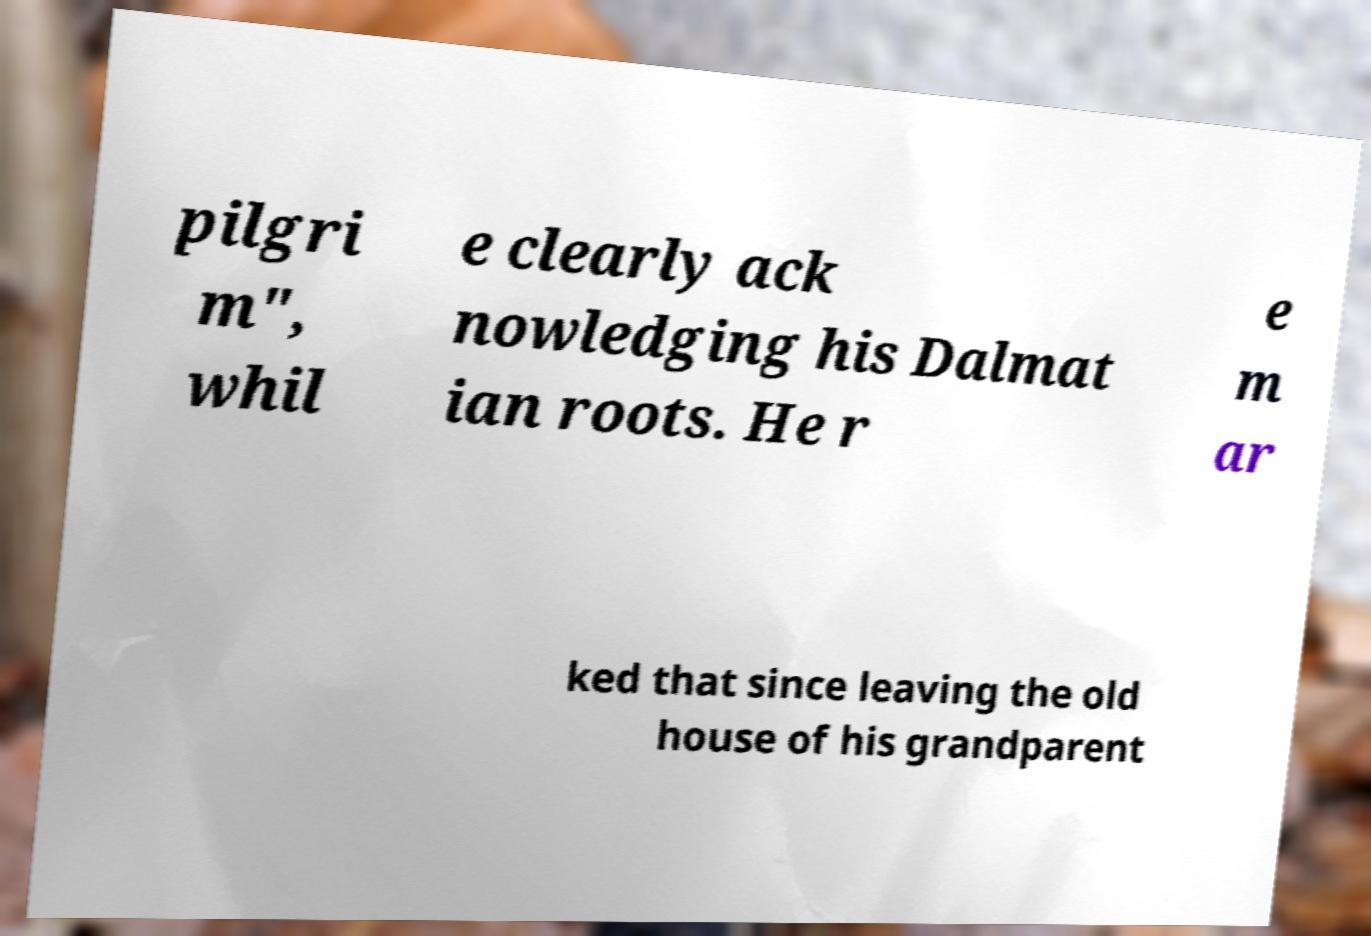What messages or text are displayed in this image? I need them in a readable, typed format. pilgri m", whil e clearly ack nowledging his Dalmat ian roots. He r e m ar ked that since leaving the old house of his grandparent 